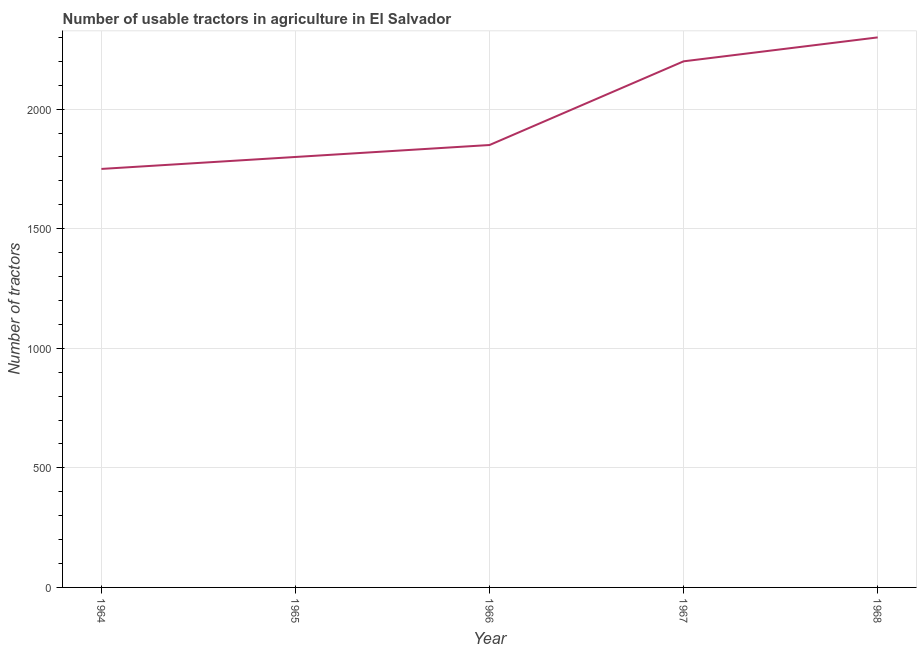What is the number of tractors in 1966?
Keep it short and to the point. 1850. Across all years, what is the maximum number of tractors?
Your response must be concise. 2300. Across all years, what is the minimum number of tractors?
Provide a succinct answer. 1750. In which year was the number of tractors maximum?
Keep it short and to the point. 1968. In which year was the number of tractors minimum?
Your answer should be very brief. 1964. What is the sum of the number of tractors?
Your response must be concise. 9900. What is the difference between the number of tractors in 1964 and 1968?
Ensure brevity in your answer.  -550. What is the average number of tractors per year?
Provide a short and direct response. 1980. What is the median number of tractors?
Provide a short and direct response. 1850. Do a majority of the years between 1966 and 1965 (inclusive) have number of tractors greater than 400 ?
Ensure brevity in your answer.  No. What is the ratio of the number of tractors in 1966 to that in 1967?
Your answer should be very brief. 0.84. Is the number of tractors in 1964 less than that in 1968?
Make the answer very short. Yes. What is the difference between the highest and the lowest number of tractors?
Provide a short and direct response. 550. In how many years, is the number of tractors greater than the average number of tractors taken over all years?
Offer a terse response. 2. Does the number of tractors monotonically increase over the years?
Your answer should be compact. Yes. How many years are there in the graph?
Your response must be concise. 5. What is the difference between two consecutive major ticks on the Y-axis?
Your answer should be compact. 500. Are the values on the major ticks of Y-axis written in scientific E-notation?
Keep it short and to the point. No. What is the title of the graph?
Offer a very short reply. Number of usable tractors in agriculture in El Salvador. What is the label or title of the X-axis?
Offer a terse response. Year. What is the label or title of the Y-axis?
Give a very brief answer. Number of tractors. What is the Number of tractors in 1964?
Your answer should be compact. 1750. What is the Number of tractors of 1965?
Make the answer very short. 1800. What is the Number of tractors in 1966?
Provide a short and direct response. 1850. What is the Number of tractors in 1967?
Provide a short and direct response. 2200. What is the Number of tractors in 1968?
Your answer should be very brief. 2300. What is the difference between the Number of tractors in 1964 and 1965?
Provide a short and direct response. -50. What is the difference between the Number of tractors in 1964 and 1966?
Your answer should be very brief. -100. What is the difference between the Number of tractors in 1964 and 1967?
Make the answer very short. -450. What is the difference between the Number of tractors in 1964 and 1968?
Your answer should be very brief. -550. What is the difference between the Number of tractors in 1965 and 1967?
Your answer should be compact. -400. What is the difference between the Number of tractors in 1965 and 1968?
Make the answer very short. -500. What is the difference between the Number of tractors in 1966 and 1967?
Your answer should be very brief. -350. What is the difference between the Number of tractors in 1966 and 1968?
Offer a very short reply. -450. What is the difference between the Number of tractors in 1967 and 1968?
Your answer should be compact. -100. What is the ratio of the Number of tractors in 1964 to that in 1966?
Give a very brief answer. 0.95. What is the ratio of the Number of tractors in 1964 to that in 1967?
Offer a very short reply. 0.8. What is the ratio of the Number of tractors in 1964 to that in 1968?
Provide a succinct answer. 0.76. What is the ratio of the Number of tractors in 1965 to that in 1967?
Ensure brevity in your answer.  0.82. What is the ratio of the Number of tractors in 1965 to that in 1968?
Keep it short and to the point. 0.78. What is the ratio of the Number of tractors in 1966 to that in 1967?
Your answer should be very brief. 0.84. What is the ratio of the Number of tractors in 1966 to that in 1968?
Provide a succinct answer. 0.8. What is the ratio of the Number of tractors in 1967 to that in 1968?
Offer a very short reply. 0.96. 